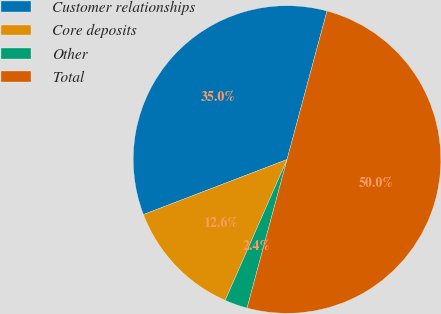Convert chart to OTSL. <chart><loc_0><loc_0><loc_500><loc_500><pie_chart><fcel>Customer relationships<fcel>Core deposits<fcel>Other<fcel>Total<nl><fcel>35.01%<fcel>12.59%<fcel>2.4%<fcel>50.0%<nl></chart> 